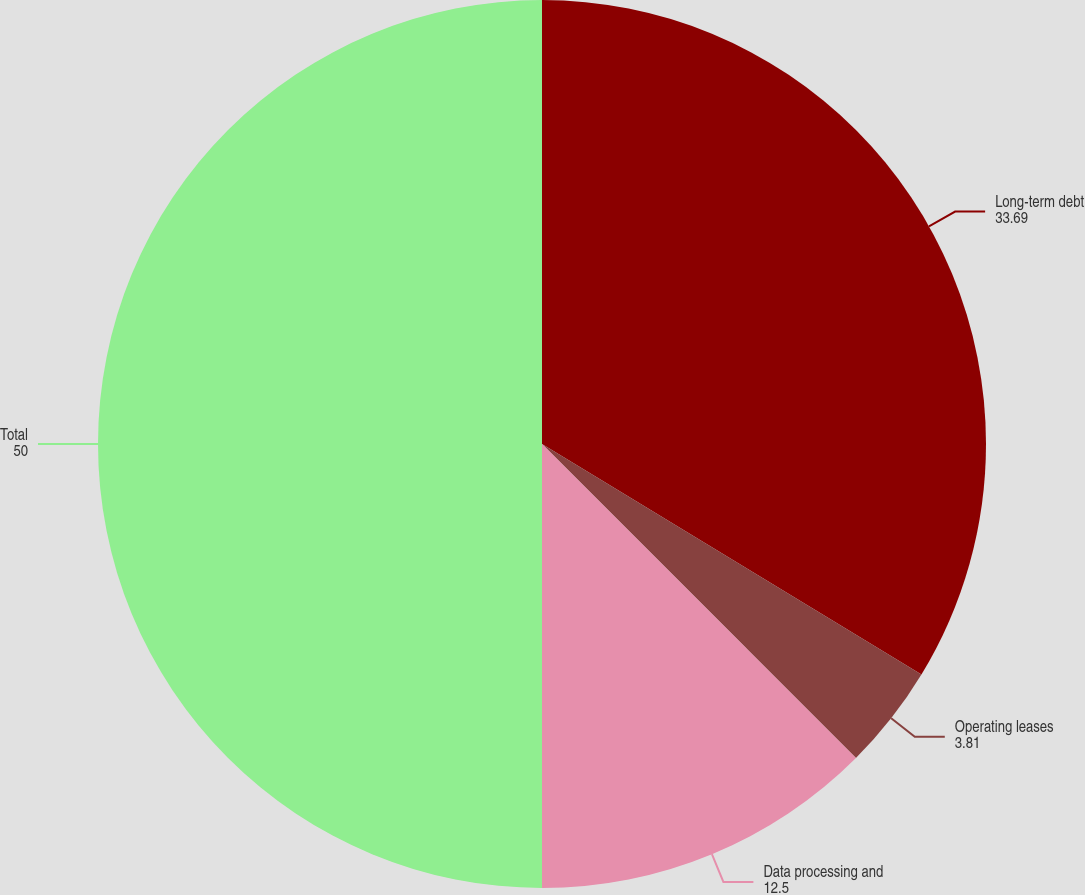<chart> <loc_0><loc_0><loc_500><loc_500><pie_chart><fcel>Long-term debt<fcel>Operating leases<fcel>Data processing and<fcel>Total<nl><fcel>33.69%<fcel>3.81%<fcel>12.5%<fcel>50.0%<nl></chart> 